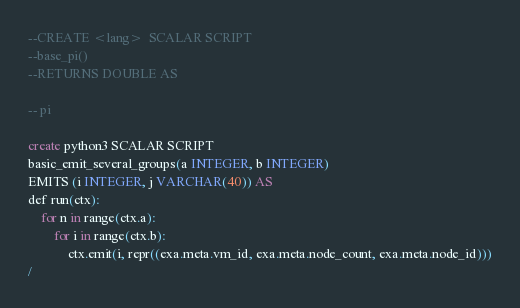<code> <loc_0><loc_0><loc_500><loc_500><_SQL_>--CREATE <lang>  SCALAR SCRIPT
--base_pi()
--RETURNS DOUBLE AS

-- pi

create python3 SCALAR SCRIPT
basic_emit_several_groups(a INTEGER, b INTEGER)
EMITS (i INTEGER, j VARCHAR(40)) AS
def run(ctx):
    for n in range(ctx.a):
        for i in range(ctx.b):
            ctx.emit(i, repr((exa.meta.vm_id, exa.meta.node_count, exa.meta.node_id)))
/

</code> 